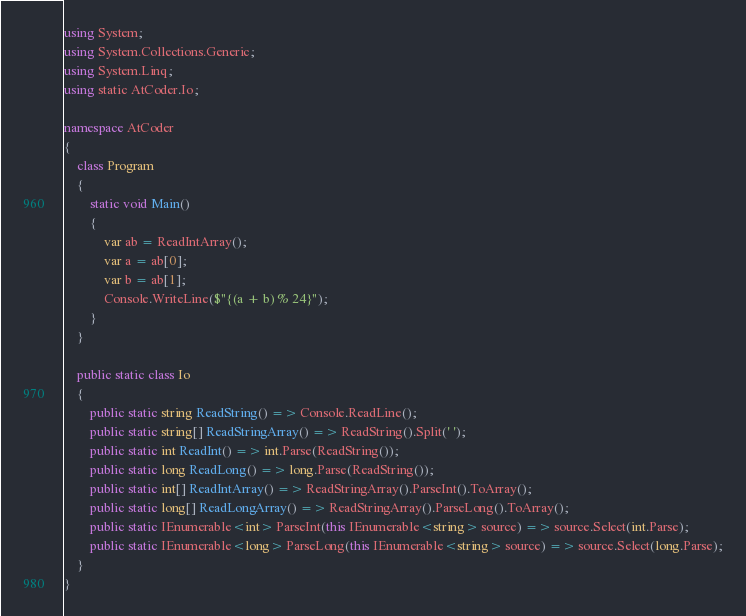<code> <loc_0><loc_0><loc_500><loc_500><_C#_>using System;
using System.Collections.Generic;
using System.Linq;
using static AtCoder.Io;

namespace AtCoder
{
    class Program
    {
        static void Main()
        {
            var ab = ReadIntArray();
            var a = ab[0];
            var b = ab[1];
            Console.WriteLine($"{(a + b) % 24}");
        }
    }

    public static class Io
    {
        public static string ReadString() => Console.ReadLine();
        public static string[] ReadStringArray() => ReadString().Split(' ');
        public static int ReadInt() => int.Parse(ReadString());
        public static long ReadLong() => long.Parse(ReadString());
        public static int[] ReadIntArray() => ReadStringArray().ParseInt().ToArray();
        public static long[] ReadLongArray() => ReadStringArray().ParseLong().ToArray();
        public static IEnumerable<int> ParseInt(this IEnumerable<string> source) => source.Select(int.Parse);
        public static IEnumerable<long> ParseLong(this IEnumerable<string> source) => source.Select(long.Parse);
    }
}
</code> 